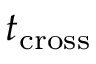<formula> <loc_0><loc_0><loc_500><loc_500>t _ { c r o s s }</formula> 